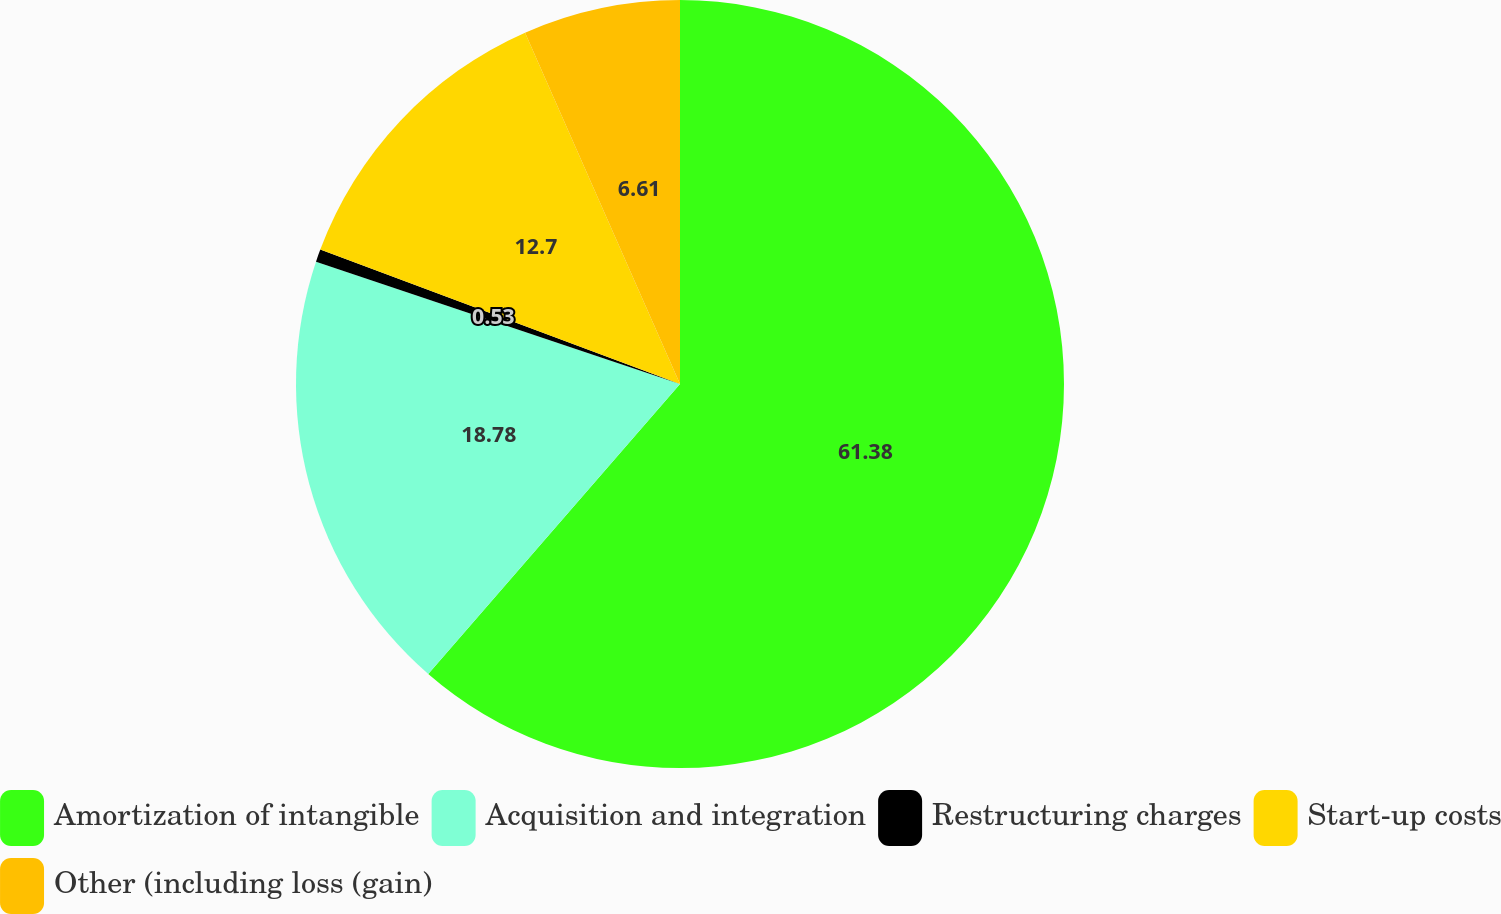Convert chart to OTSL. <chart><loc_0><loc_0><loc_500><loc_500><pie_chart><fcel>Amortization of intangible<fcel>Acquisition and integration<fcel>Restructuring charges<fcel>Start-up costs<fcel>Other (including loss (gain)<nl><fcel>61.38%<fcel>18.78%<fcel>0.53%<fcel>12.7%<fcel>6.61%<nl></chart> 